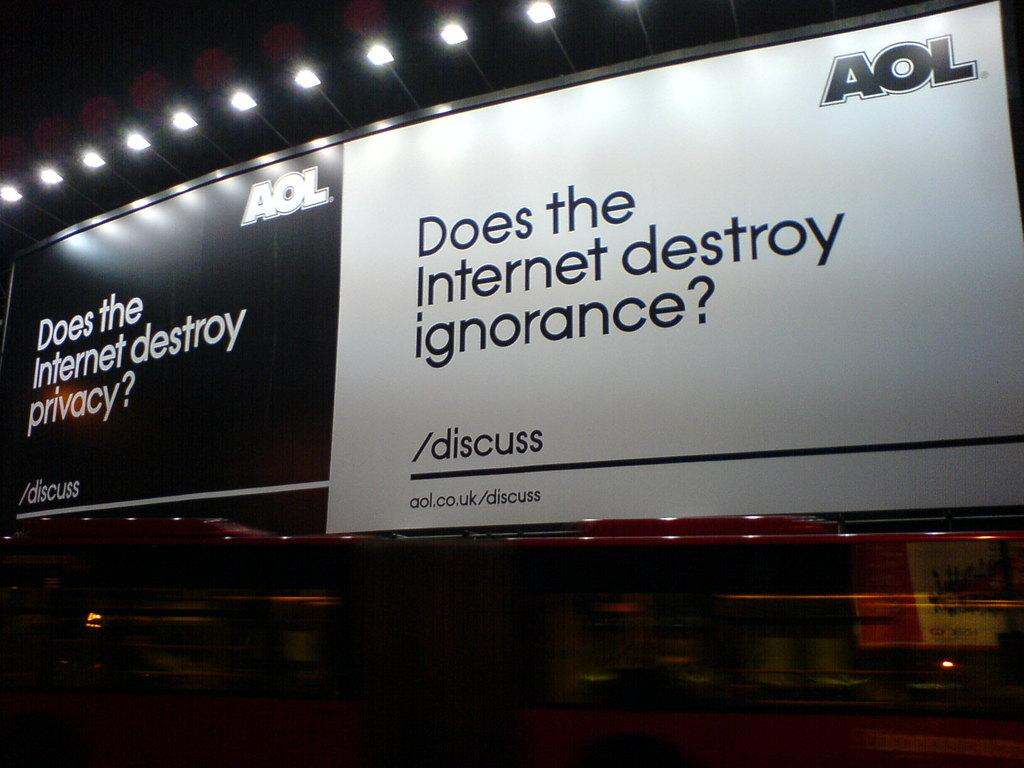Provide a one-sentence caption for the provided image. A pair of banners that are advertisements for AOL talking about privacy and ignorance. 